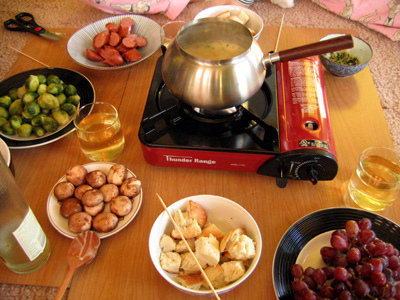<image>
Is there a fondue in the pot? Yes. The fondue is contained within or inside the pot, showing a containment relationship. Is the spoon in the bread cubes? No. The spoon is not contained within the bread cubes. These objects have a different spatial relationship. Is the skewer on the table? No. The skewer is not positioned on the table. They may be near each other, but the skewer is not supported by or resting on top of the table. 